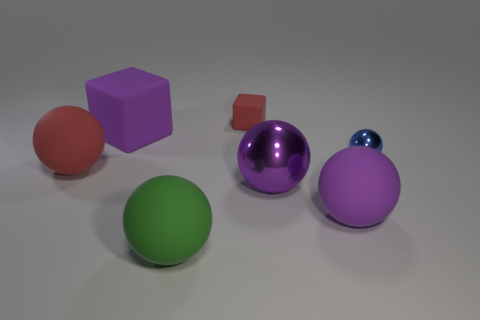Subtract all small blue balls. How many balls are left? 4 Add 3 metal things. How many objects exist? 10 Subtract all brown cylinders. How many purple spheres are left? 2 Subtract 2 spheres. How many spheres are left? 3 Subtract all blue spheres. How many spheres are left? 4 Subtract all blocks. How many objects are left? 5 Subtract all purple spheres. Subtract all cyan cylinders. How many spheres are left? 3 Subtract 1 green spheres. How many objects are left? 6 Subtract all big green objects. Subtract all tiny rubber things. How many objects are left? 5 Add 7 big purple metal spheres. How many big purple metal spheres are left? 8 